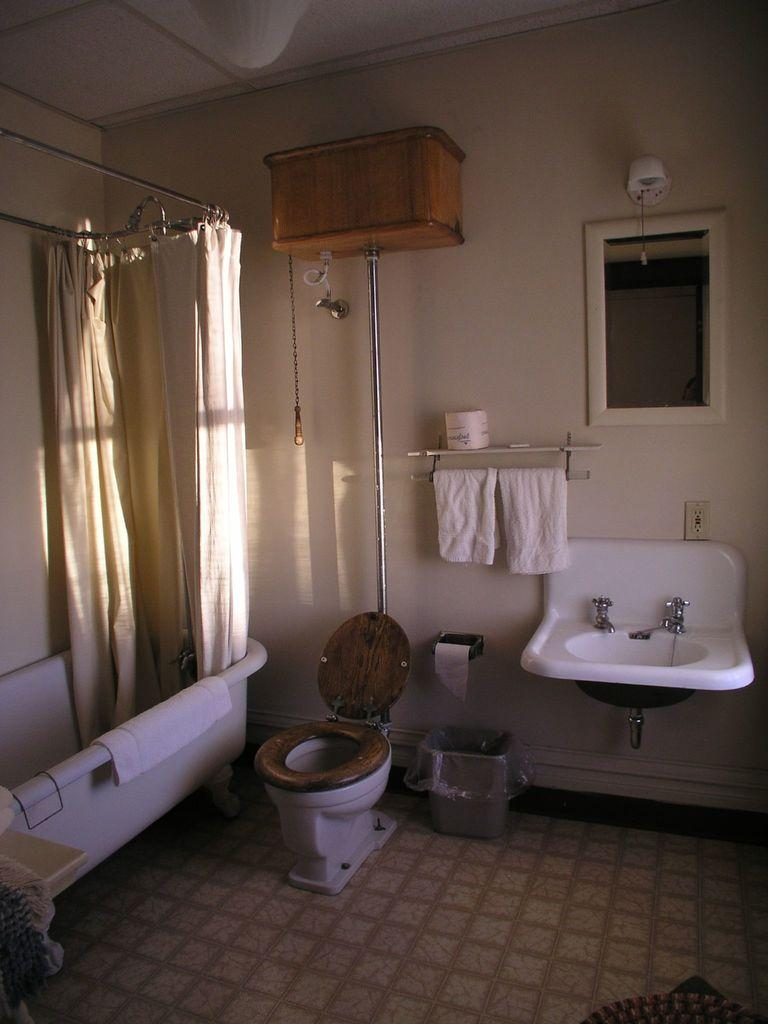What type of fixture is located on the left side of the image? There is a bath tub on the left side of the image. What other fixtures can be seen in the image? There is a washbasin, a mirror, and a commode in the image. Is there a slope visible in the image? No, there is no slope present in the image. How many visitors are in the image? There is no indication of any visitors in the image. 